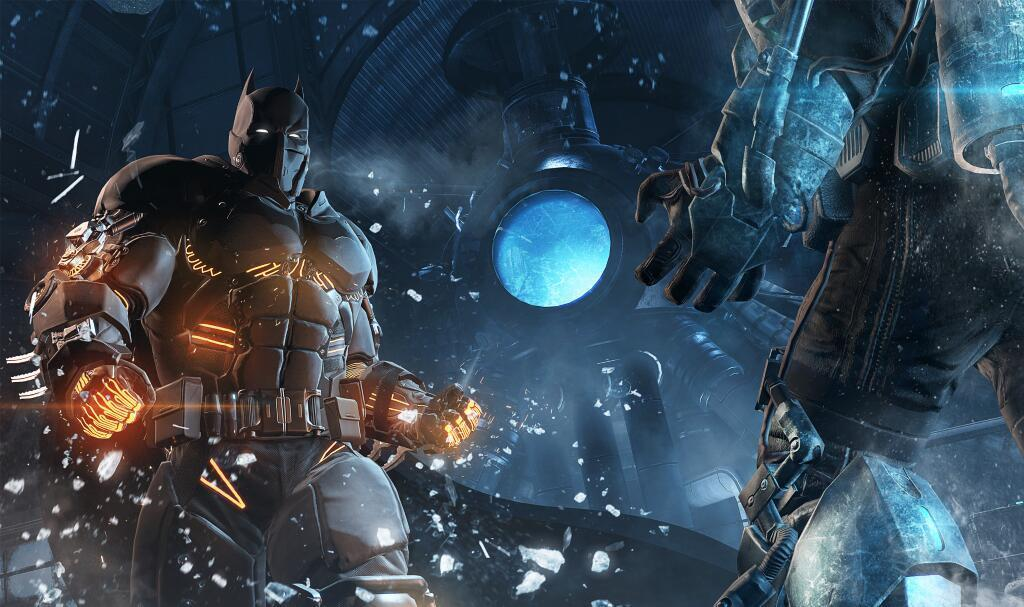How many people are in the image? There are two persons in the image. What are the persons wearing? The persons are wearing dresses and masks. What type of image is it? The image is animated. What type of coach can be seen in the image? There is no coach present in the image. What fruit is being folded in the image? There is no fruit or folding action depicted in the image. 